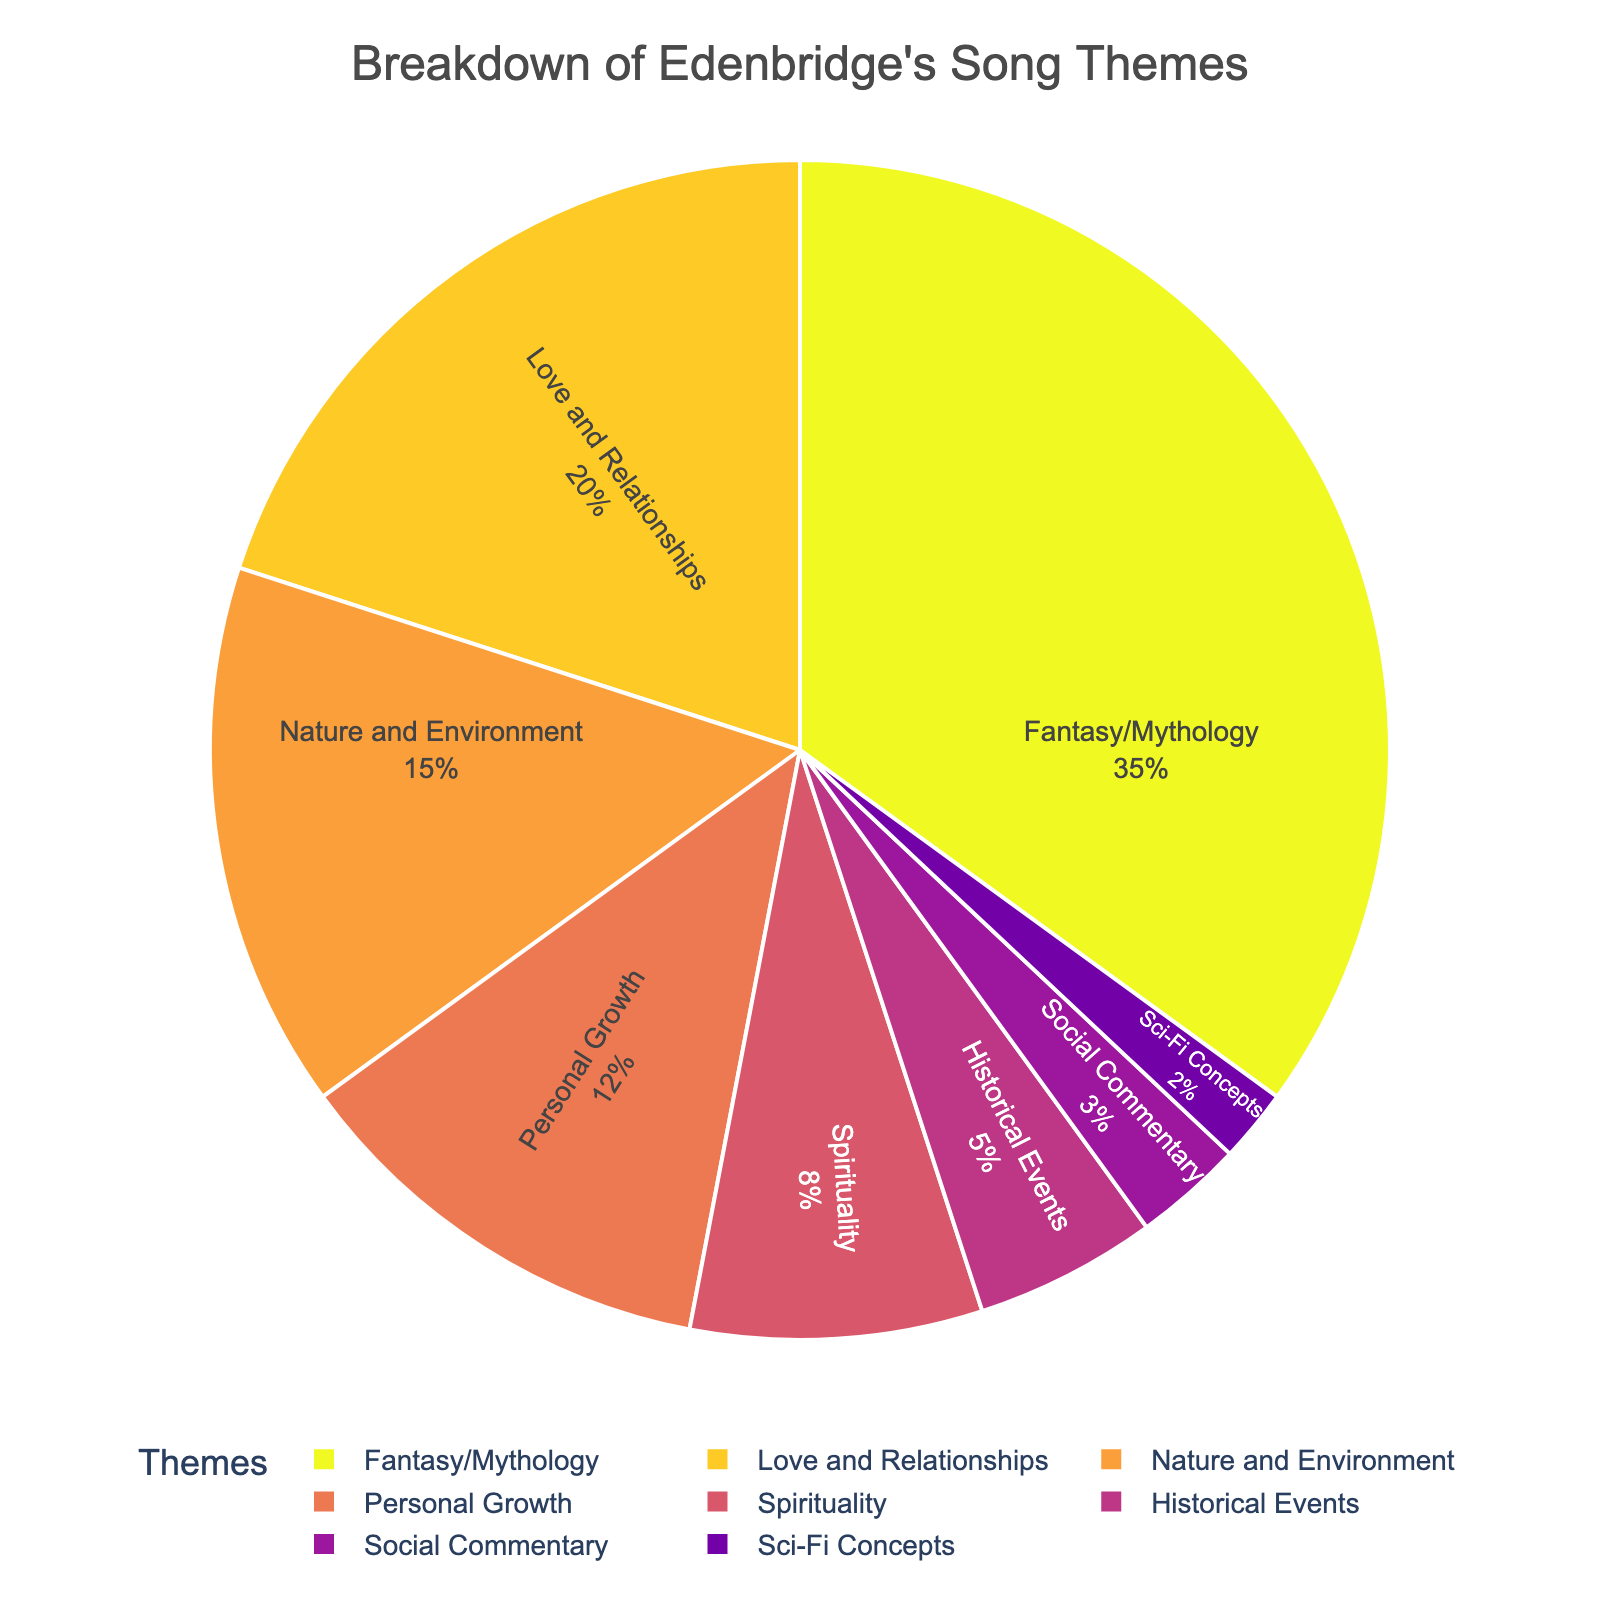Which theme has the highest percentage of songs? By examining the pie chart, the largest segment represents the theme that occupies the highest percentage.
Answer: Fantasy/Mythology How much higher is the percentage of Love and Relationships compared to Historical Events? To find the difference, subtract the percentage of Historical Events (5%) from the percentage of Love and Relationships (20%).
Answer: 15% What is the combined percentage of songs with themes related to Personal Growth and Spirituality? Add the percentages of Personal Growth (12%) and Spirituality (8%) together.
Answer: 20% Which two themes together make up 15% of Edenbridge's songs? Look for two themes whose summed percentages equal 15%. Nature and Environment (15%) fits this requirement, but it is a single theme. Another pair doesn't fit exactly, indicating just one theme at 15%.
Answer: Nature and Environment Are there more songs about Nature and Environment or Personal Growth? Compare the percentages: Nature and Environment (15%) is greater than Personal Growth (12%).
Answer: Nature and Environment What's the percentage difference between Fantasy/Mythology and the smallest theme? Fantasy/Mythology is 35%, and Sci-Fi Concepts is the smallest at 2%. Subtract 2% from 35% to get the difference.
Answer: 33% Which theme is twice as prevalent as Social Commentary? Social Commentary is 3%, so the theme that is twice this would be 6%, but Spirituality at 8% is closest to being more than twice.
Answer: Spirituality If you remove the Historical Events theme, what would be the new percentage total for Love and Relationships and Personal Growth combined? First, add the percentages for Love and Relationships (20%) and Personal Growth (12%) to get 32%. Removing Historical Events doesn't alter this sum.
Answer: 32% Is the percentage of songs with Sci-Fi Concepts greater than the aggregate of all themes under 10% combined? The percentage of Sci-Fi Concepts is 2%. Aggregate of Historical Events (5%) + Social Commentary (3%) = 8%. Sci-Fi Concepts (2%) is not greater.
Answer: No What fraction of the pie chart is made up of songs about Personal Growth? Convert the percentage of Personal Growth (12%) to a fraction.
Answer: 12/100 or simplified 3/25 